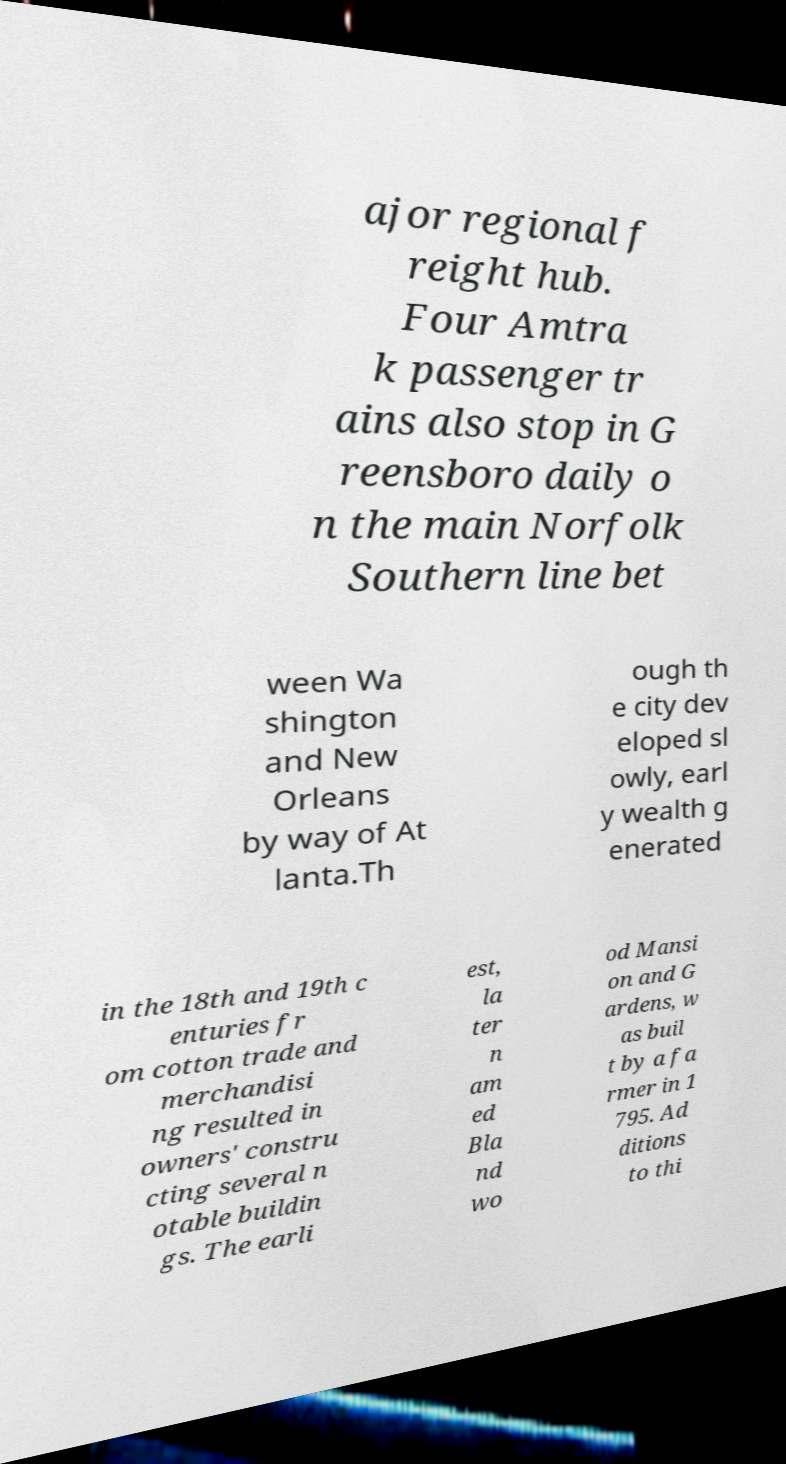Please identify and transcribe the text found in this image. ajor regional f reight hub. Four Amtra k passenger tr ains also stop in G reensboro daily o n the main Norfolk Southern line bet ween Wa shington and New Orleans by way of At lanta.Th ough th e city dev eloped sl owly, earl y wealth g enerated in the 18th and 19th c enturies fr om cotton trade and merchandisi ng resulted in owners' constru cting several n otable buildin gs. The earli est, la ter n am ed Bla nd wo od Mansi on and G ardens, w as buil t by a fa rmer in 1 795. Ad ditions to thi 